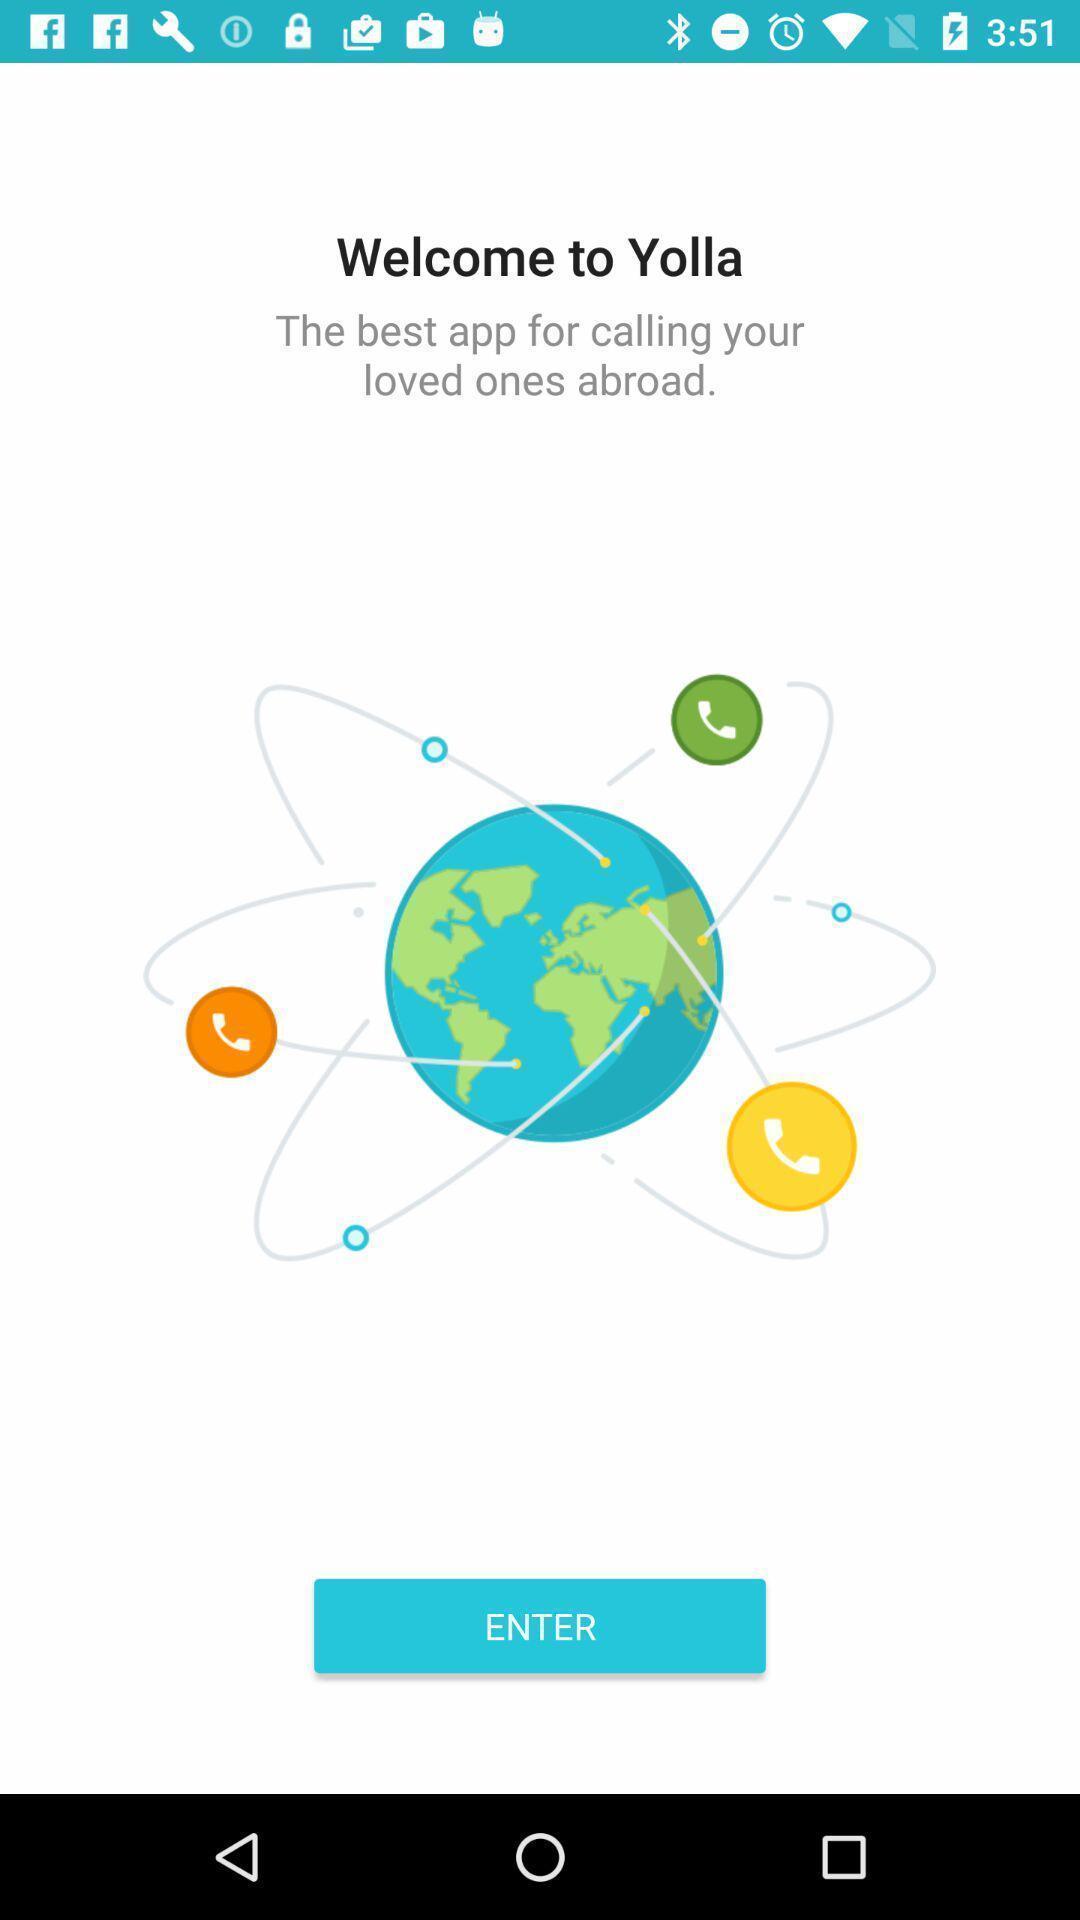Explain what's happening in this screen capture. Welcome page of an calling app. 